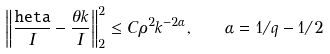Convert formula to latex. <formula><loc_0><loc_0><loc_500><loc_500>\left \| \frac { \tt h e t a } { I } - \frac { \theta k } { I } \right \| ^ { 2 } _ { 2 } \leq C \rho ^ { 2 } k ^ { - 2 \alpha } , \quad \alpha = 1 / q - 1 / 2</formula> 